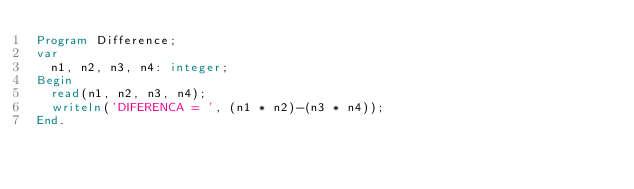Convert code to text. <code><loc_0><loc_0><loc_500><loc_500><_Pascal_>Program Difference;
var
	n1, n2, n3, n4: integer;
Begin
	read(n1, n2, n3, n4);
	writeln('DIFERENCA = ', (n1 * n2)-(n3 * n4));
End.</code> 